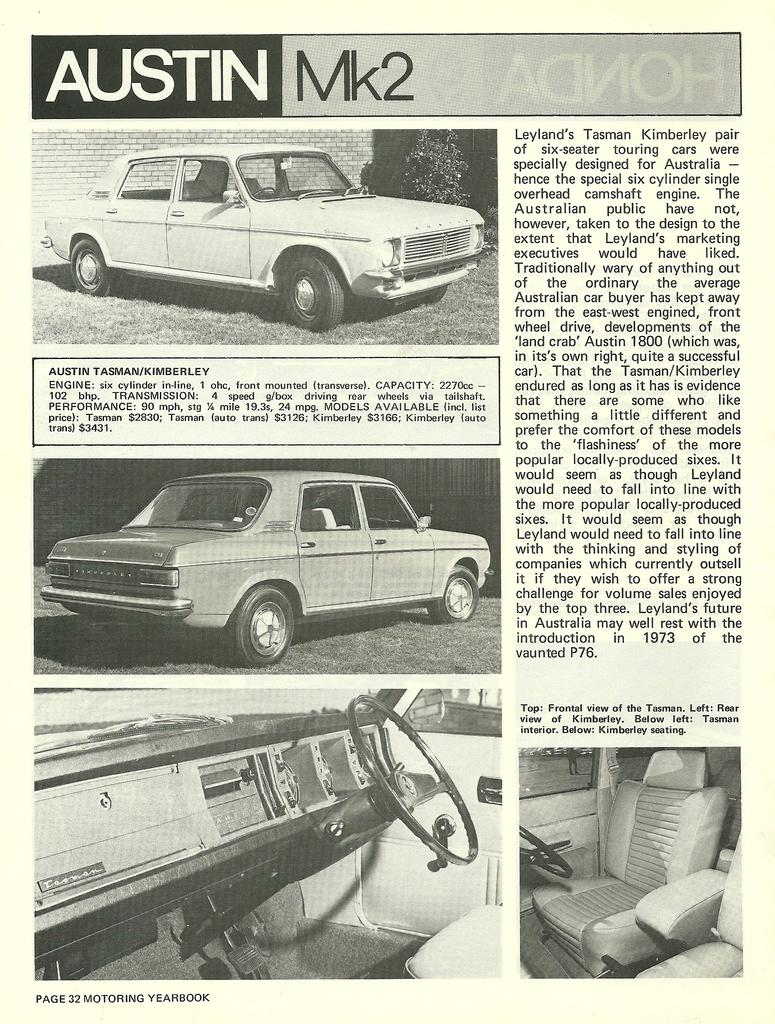What type of art is depicted in the image? The image is a paper cutting. What subject matter is featured in the paper cutting? There are pictures of car interiors in the image. Is there any text present in the image? Yes, there is text present in the image. How many pets can be seen playing with ants in the image? There are no pets or ants present in the image; it features pictures of car interiors and text. 